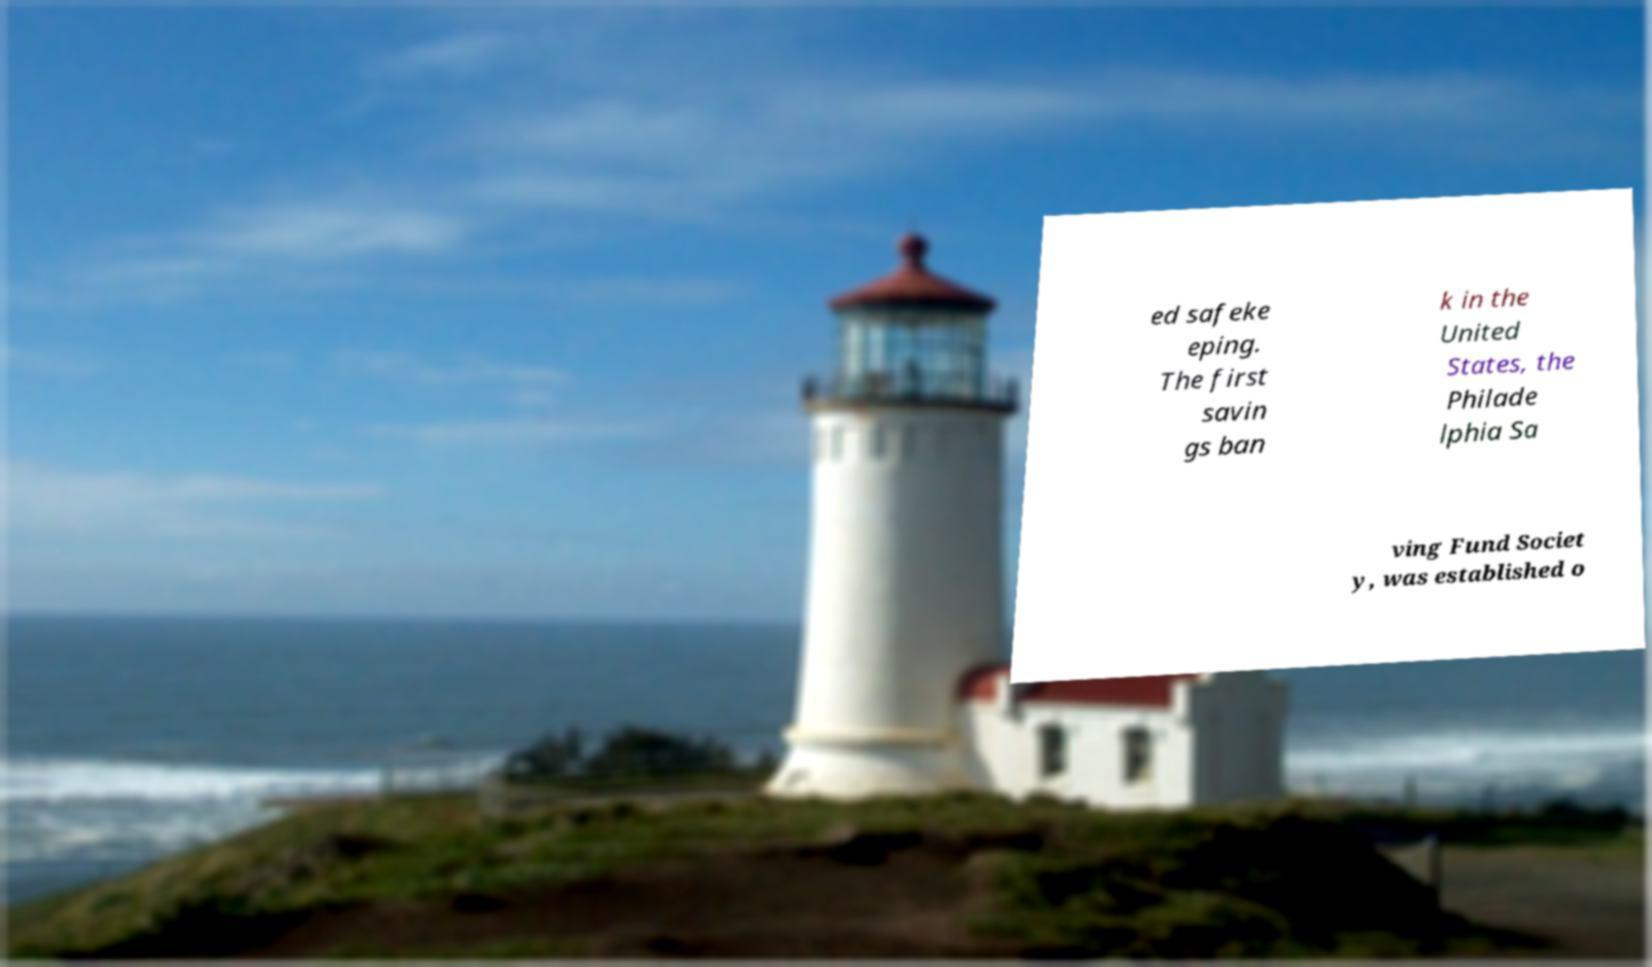Could you extract and type out the text from this image? ed safeke eping. The first savin gs ban k in the United States, the Philade lphia Sa ving Fund Societ y, was established o 